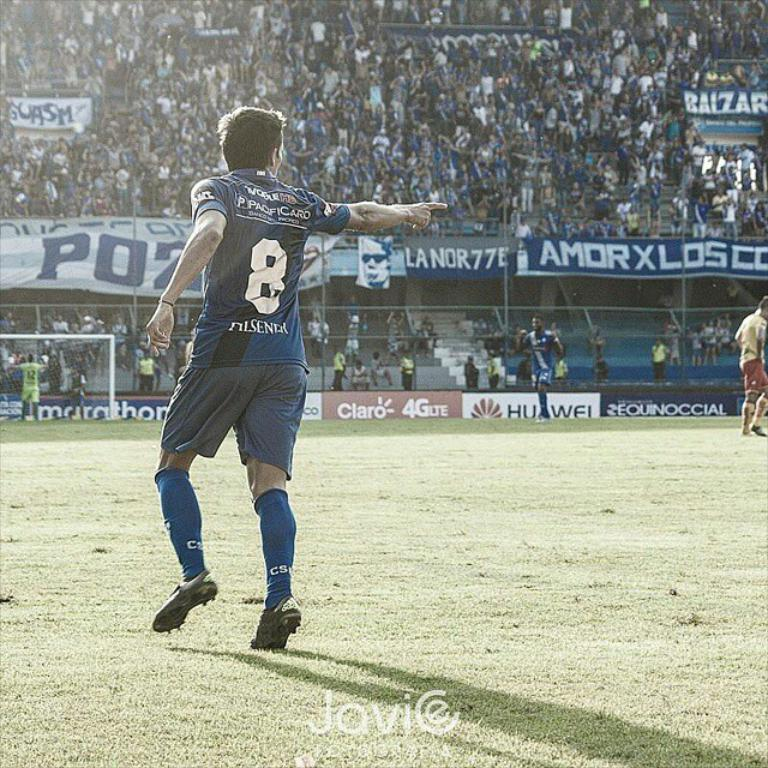<image>
Provide a brief description of the given image. A soccer player with the number 8 on his shirt 